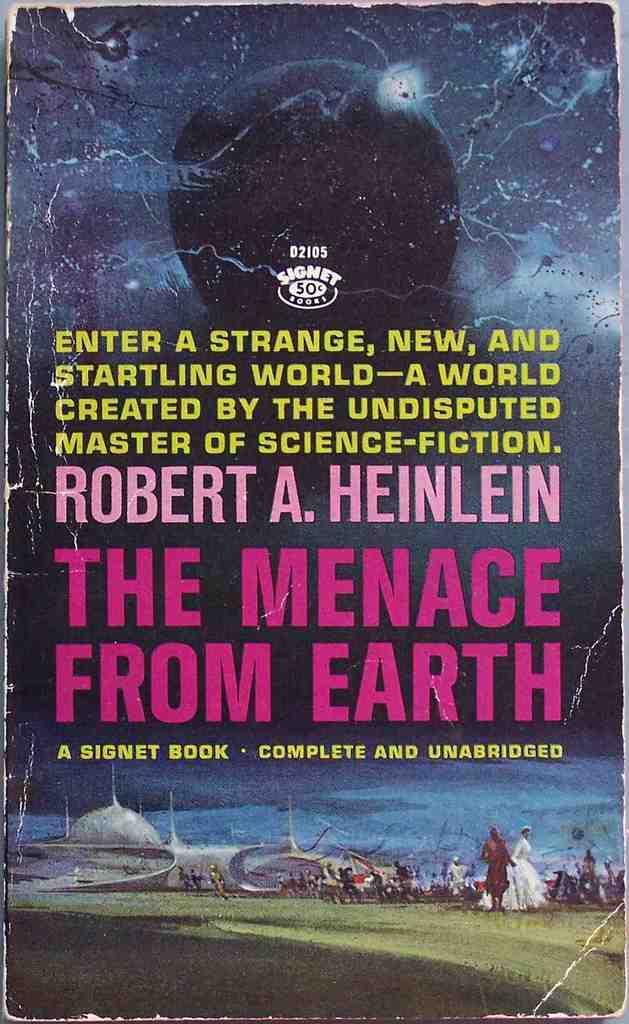<image>
Offer a succinct explanation of the picture presented. A book that is titled The Menace From Earth. 